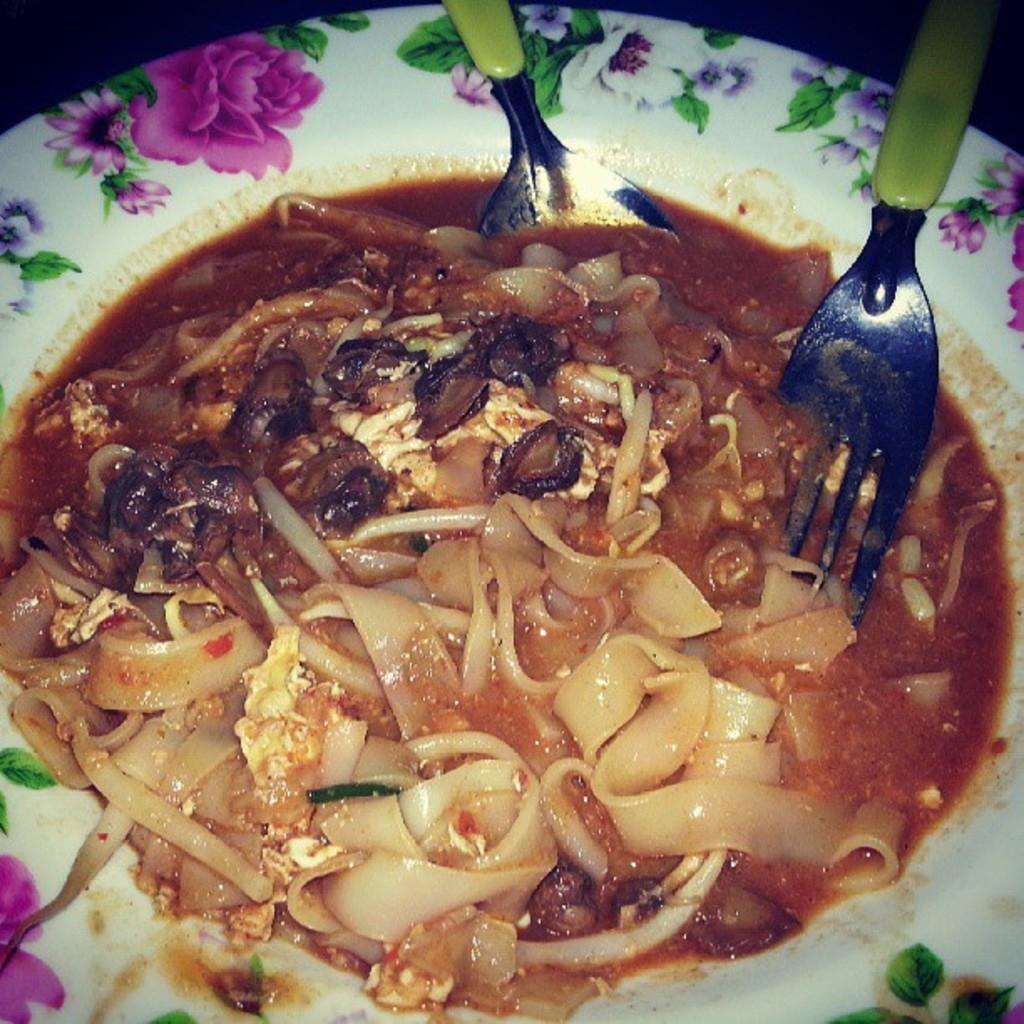What object is present in the image that is typically used for serving or eating food? There is a plate in the image. What is on the plate in the image? There is food on the plate. How many utensils are visible in the image? There are two spoons in the image. What part of the body is responsible for digestion in the image? There is no part of the body present in the image, as it only features a plate with food and two spoons. 